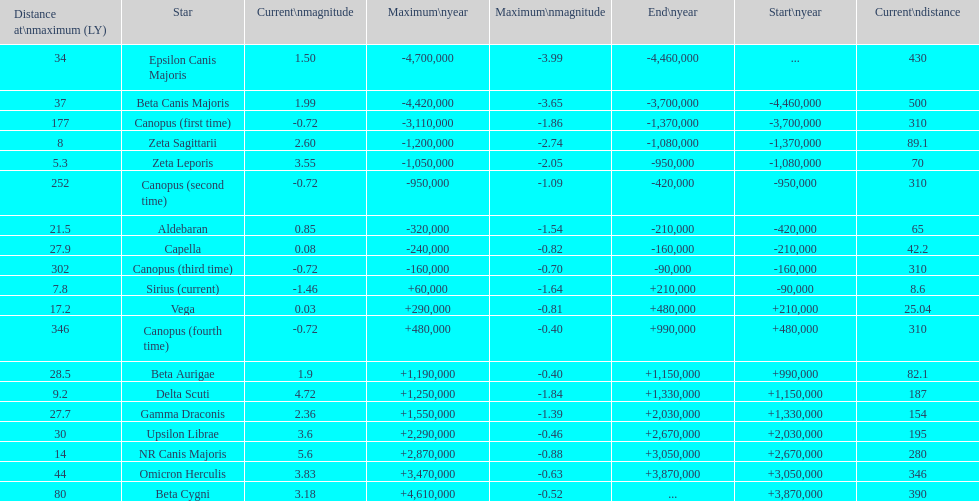What is the number of stars that have a maximum magnitude less than zero? 5. Parse the full table. {'header': ['Distance at\\nmaximum (LY)', 'Star', 'Current\\nmagnitude', 'Maximum\\nyear', 'Maximum\\nmagnitude', 'End\\nyear', 'Start\\nyear', 'Current\\ndistance'], 'rows': [['34', 'Epsilon Canis Majoris', '1.50', '-4,700,000', '-3.99', '-4,460,000', '...', '430'], ['37', 'Beta Canis Majoris', '1.99', '-4,420,000', '-3.65', '-3,700,000', '-4,460,000', '500'], ['177', 'Canopus (first time)', '-0.72', '-3,110,000', '-1.86', '-1,370,000', '-3,700,000', '310'], ['8', 'Zeta Sagittarii', '2.60', '-1,200,000', '-2.74', '-1,080,000', '-1,370,000', '89.1'], ['5.3', 'Zeta Leporis', '3.55', '-1,050,000', '-2.05', '-950,000', '-1,080,000', '70'], ['252', 'Canopus (second time)', '-0.72', '-950,000', '-1.09', '-420,000', '-950,000', '310'], ['21.5', 'Aldebaran', '0.85', '-320,000', '-1.54', '-210,000', '-420,000', '65'], ['27.9', 'Capella', '0.08', '-240,000', '-0.82', '-160,000', '-210,000', '42.2'], ['302', 'Canopus (third time)', '-0.72', '-160,000', '-0.70', '-90,000', '-160,000', '310'], ['7.8', 'Sirius (current)', '-1.46', '+60,000', '-1.64', '+210,000', '-90,000', '8.6'], ['17.2', 'Vega', '0.03', '+290,000', '-0.81', '+480,000', '+210,000', '25.04'], ['346', 'Canopus (fourth time)', '-0.72', '+480,000', '-0.40', '+990,000', '+480,000', '310'], ['28.5', 'Beta Aurigae', '1.9', '+1,190,000', '-0.40', '+1,150,000', '+990,000', '82.1'], ['9.2', 'Delta Scuti', '4.72', '+1,250,000', '-1.84', '+1,330,000', '+1,150,000', '187'], ['27.7', 'Gamma Draconis', '2.36', '+1,550,000', '-1.39', '+2,030,000', '+1,330,000', '154'], ['30', 'Upsilon Librae', '3.6', '+2,290,000', '-0.46', '+2,670,000', '+2,030,000', '195'], ['14', 'NR Canis Majoris', '5.6', '+2,870,000', '-0.88', '+3,050,000', '+2,670,000', '280'], ['44', 'Omicron Herculis', '3.83', '+3,470,000', '-0.63', '+3,870,000', '+3,050,000', '346'], ['80', 'Beta Cygni', '3.18', '+4,610,000', '-0.52', '...', '+3,870,000', '390']]} 